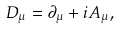Convert formula to latex. <formula><loc_0><loc_0><loc_500><loc_500>D _ { \mu } = \partial _ { \mu } + i A _ { \mu } ,</formula> 